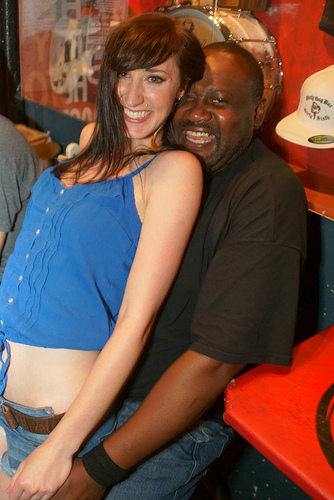<image>
Is there a hat on the head? No. The hat is not positioned on the head. They may be near each other, but the hat is not supported by or resting on top of the head. 